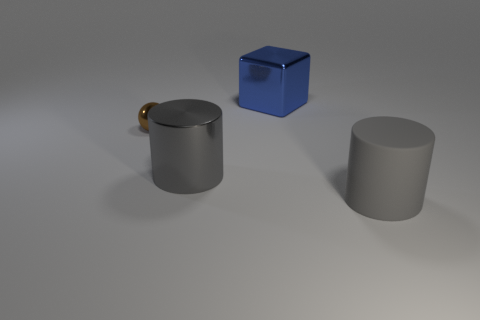Is there a big gray shiny thing on the right side of the gray cylinder on the left side of the gray thing right of the large shiny block?
Offer a terse response. No. Do the brown ball and the metal cube have the same size?
Keep it short and to the point. No. There is a large cylinder that is left of the cylinder to the right of the big cylinder that is left of the big blue object; what is its color?
Offer a terse response. Gray. How many large objects are the same color as the big metal cylinder?
Your answer should be very brief. 1. What number of large things are either gray metal cylinders or cyan objects?
Your answer should be compact. 1. Are there any other gray metal objects of the same shape as the large gray metal thing?
Offer a terse response. No. Do the gray metallic object and the tiny brown metallic thing have the same shape?
Provide a short and direct response. No. What color is the cylinder that is on the left side of the thing that is behind the tiny thing?
Provide a short and direct response. Gray. There is a shiny block that is the same size as the gray matte thing; what color is it?
Give a very brief answer. Blue. What number of rubber objects are tiny balls or small red cylinders?
Offer a terse response. 0. 